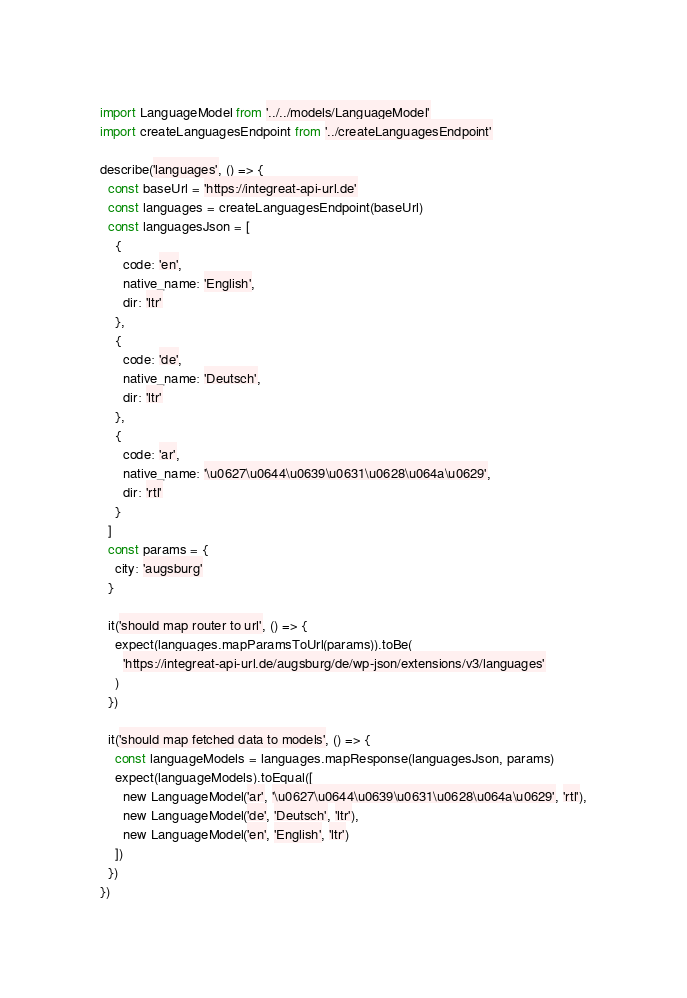<code> <loc_0><loc_0><loc_500><loc_500><_TypeScript_>import LanguageModel from '../../models/LanguageModel'
import createLanguagesEndpoint from '../createLanguagesEndpoint'

describe('languages', () => {
  const baseUrl = 'https://integreat-api-url.de'
  const languages = createLanguagesEndpoint(baseUrl)
  const languagesJson = [
    {
      code: 'en',
      native_name: 'English',
      dir: 'ltr'
    },
    {
      code: 'de',
      native_name: 'Deutsch',
      dir: 'ltr'
    },
    {
      code: 'ar',
      native_name: '\u0627\u0644\u0639\u0631\u0628\u064a\u0629',
      dir: 'rtl'
    }
  ]
  const params = {
    city: 'augsburg'
  }

  it('should map router to url', () => {
    expect(languages.mapParamsToUrl(params)).toBe(
      'https://integreat-api-url.de/augsburg/de/wp-json/extensions/v3/languages'
    )
  })

  it('should map fetched data to models', () => {
    const languageModels = languages.mapResponse(languagesJson, params)
    expect(languageModels).toEqual([
      new LanguageModel('ar', '\u0627\u0644\u0639\u0631\u0628\u064a\u0629', 'rtl'),
      new LanguageModel('de', 'Deutsch', 'ltr'),
      new LanguageModel('en', 'English', 'ltr')
    ])
  })
})
</code> 